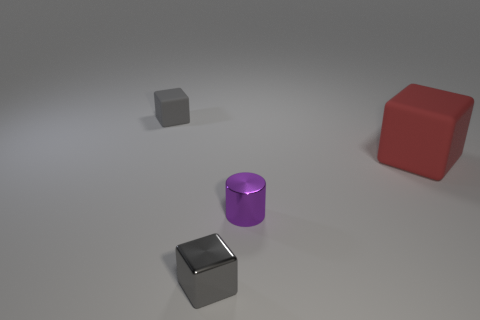Subtract all big matte cubes. How many cubes are left? 2 Add 2 big blue rubber balls. How many objects exist? 6 Subtract all red cubes. How many cubes are left? 2 Subtract all cubes. How many objects are left? 1 Subtract 1 blocks. How many blocks are left? 2 Subtract all brown blocks. Subtract all green cylinders. How many blocks are left? 3 Subtract all blue cylinders. How many gray cubes are left? 2 Subtract all tiny green shiny cylinders. Subtract all gray shiny objects. How many objects are left? 3 Add 3 tiny objects. How many tiny objects are left? 6 Add 2 gray metallic objects. How many gray metallic objects exist? 3 